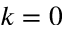Convert formula to latex. <formula><loc_0><loc_0><loc_500><loc_500>k = 0</formula> 